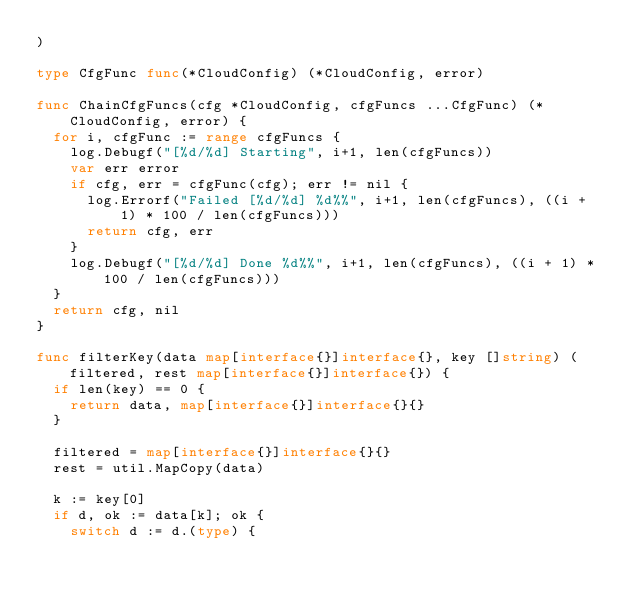<code> <loc_0><loc_0><loc_500><loc_500><_Go_>)

type CfgFunc func(*CloudConfig) (*CloudConfig, error)

func ChainCfgFuncs(cfg *CloudConfig, cfgFuncs ...CfgFunc) (*CloudConfig, error) {
	for i, cfgFunc := range cfgFuncs {
		log.Debugf("[%d/%d] Starting", i+1, len(cfgFuncs))
		var err error
		if cfg, err = cfgFunc(cfg); err != nil {
			log.Errorf("Failed [%d/%d] %d%%", i+1, len(cfgFuncs), ((i + 1) * 100 / len(cfgFuncs)))
			return cfg, err
		}
		log.Debugf("[%d/%d] Done %d%%", i+1, len(cfgFuncs), ((i + 1) * 100 / len(cfgFuncs)))
	}
	return cfg, nil
}

func filterKey(data map[interface{}]interface{}, key []string) (filtered, rest map[interface{}]interface{}) {
	if len(key) == 0 {
		return data, map[interface{}]interface{}{}
	}

	filtered = map[interface{}]interface{}{}
	rest = util.MapCopy(data)

	k := key[0]
	if d, ok := data[k]; ok {
		switch d := d.(type) {
</code> 